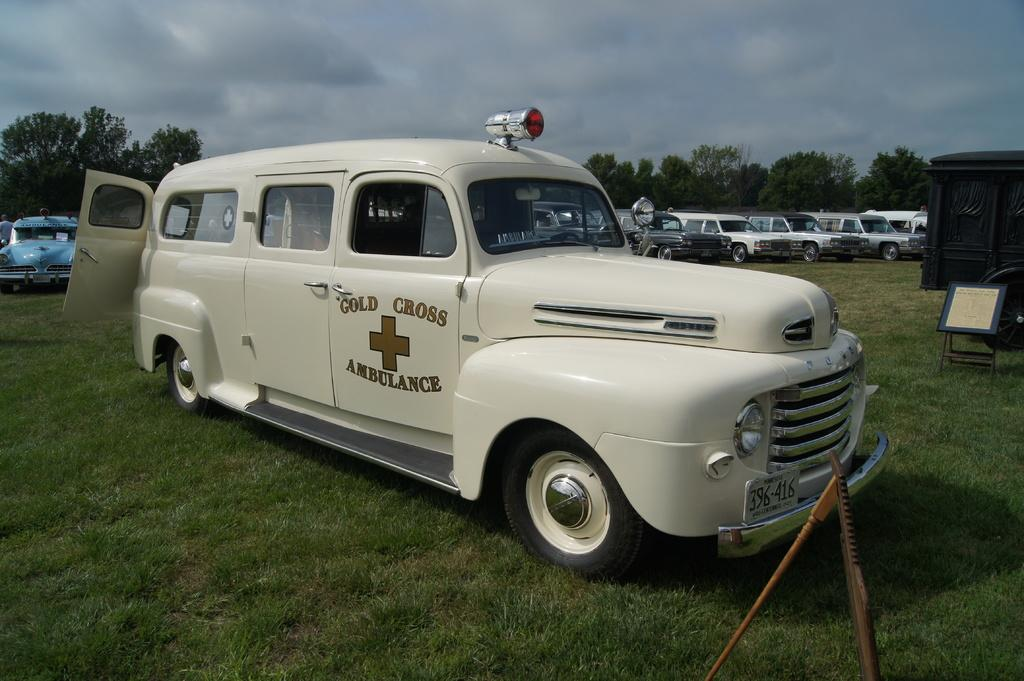Provide a one-sentence caption for the provided image. An antique gold cross ambulance is parked on grass with other old vehicles parked behind it. 